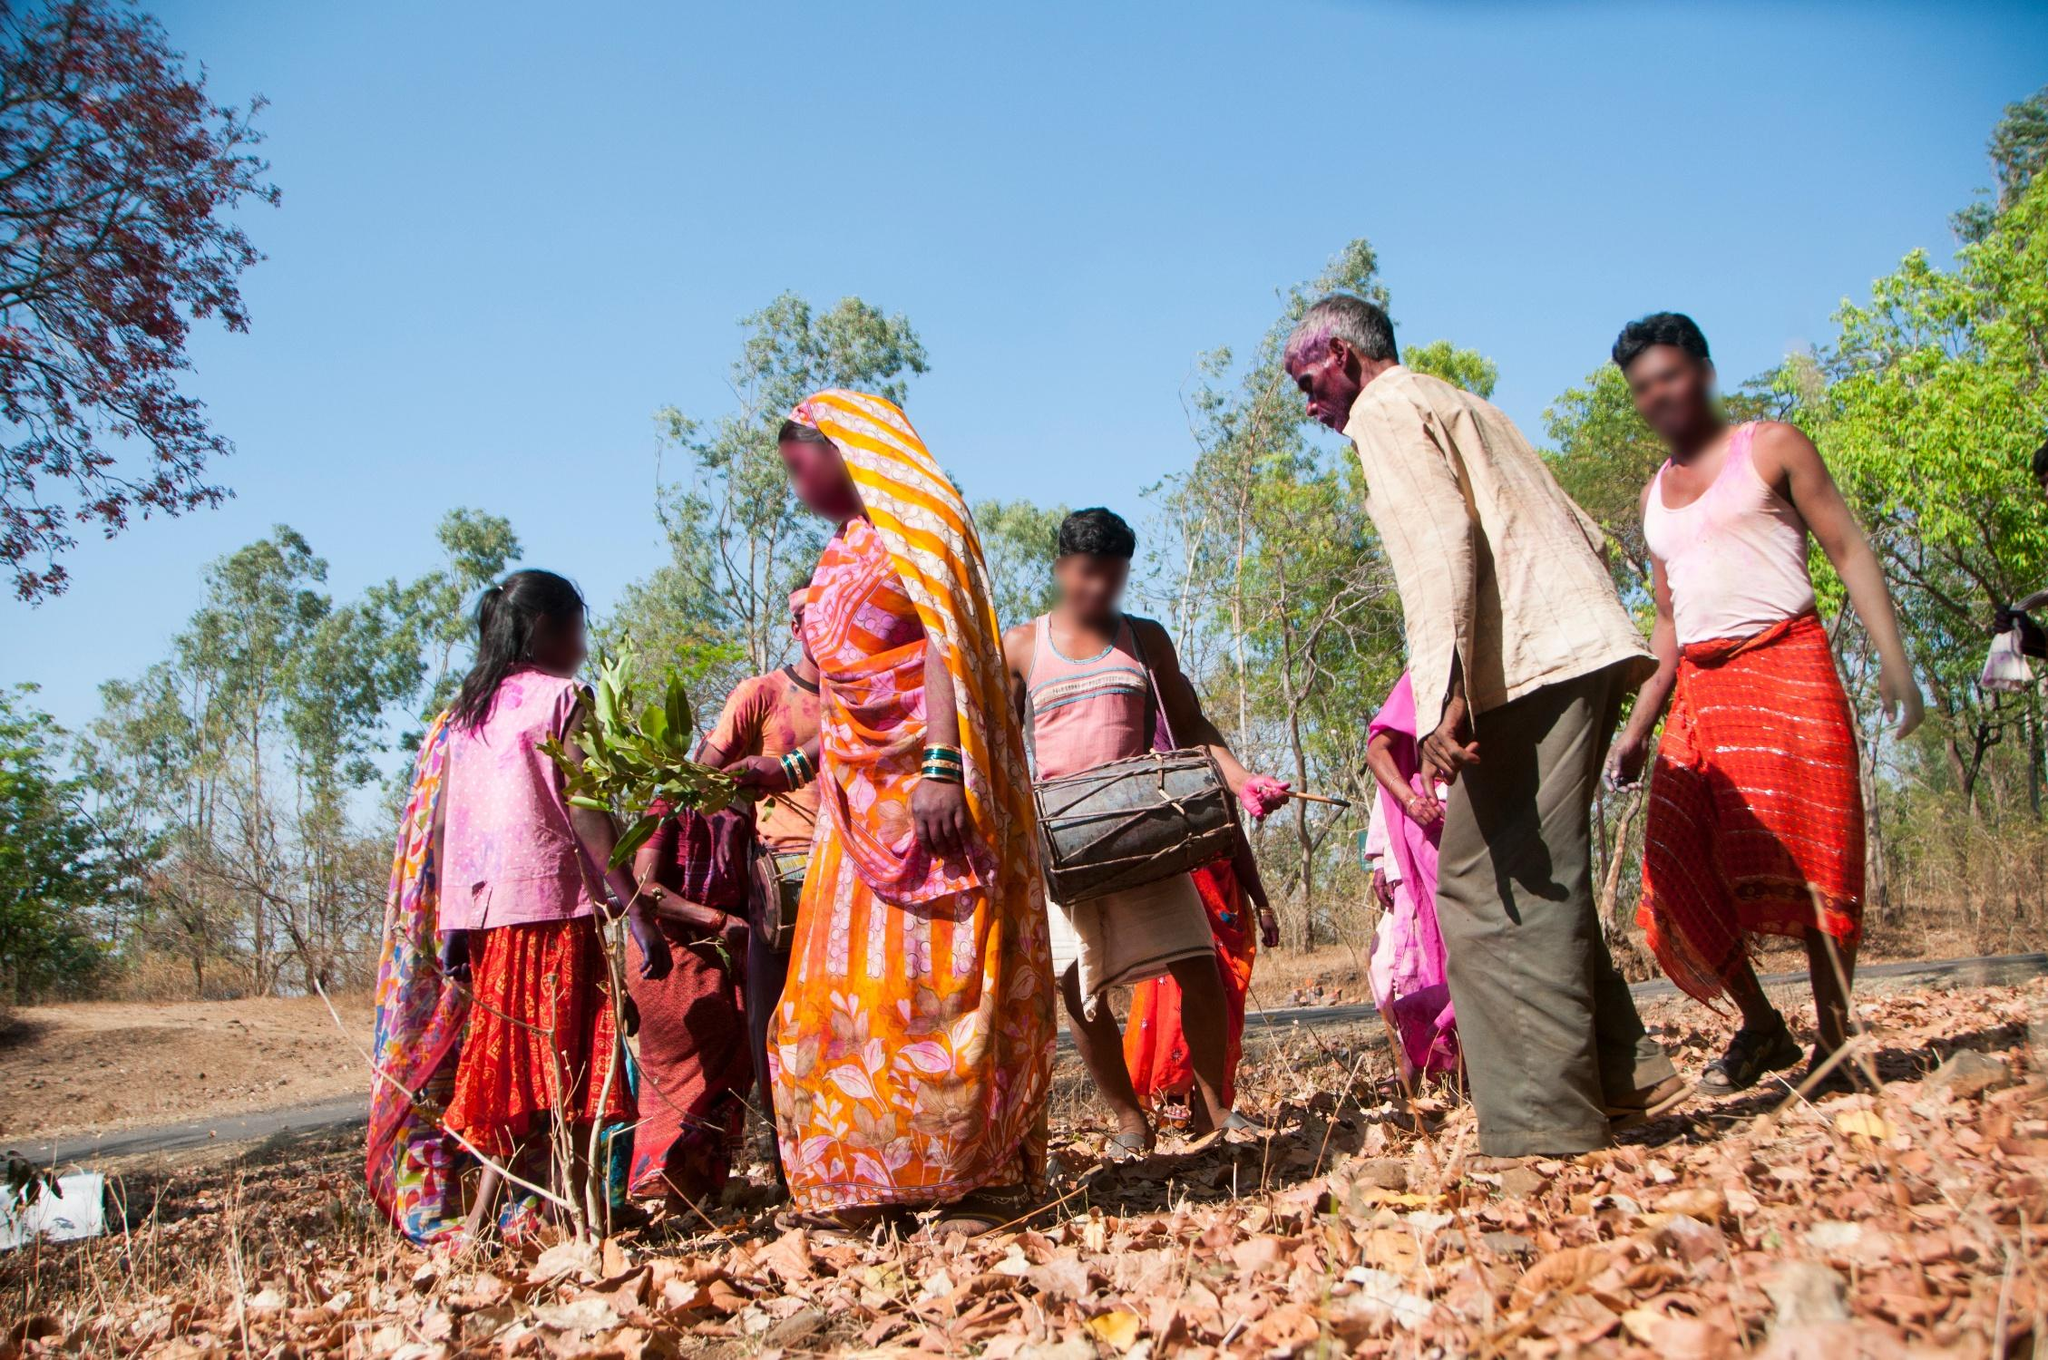Can you elaborate on the elements of the picture provided? The image captures a dynamic scene with a group of people engaged in an outdoor activity, possibly related to farming or harvesting. They are dressed in vibrant and colorful traditional clothing that vividly contrasts with the earthy tones of the field and the lush green trees in the background. Various tools and baskets carried by the individuals suggest that they are working together on a common task, emphasizing a sense of community and collaboration. The low-angle perspective enhances the depth and scale of the scene, highlighting the vastness of the field and the collective effort of the group. The setting exudes an atmosphere of hard work, cultural richness, and harmony with their natural environment. 